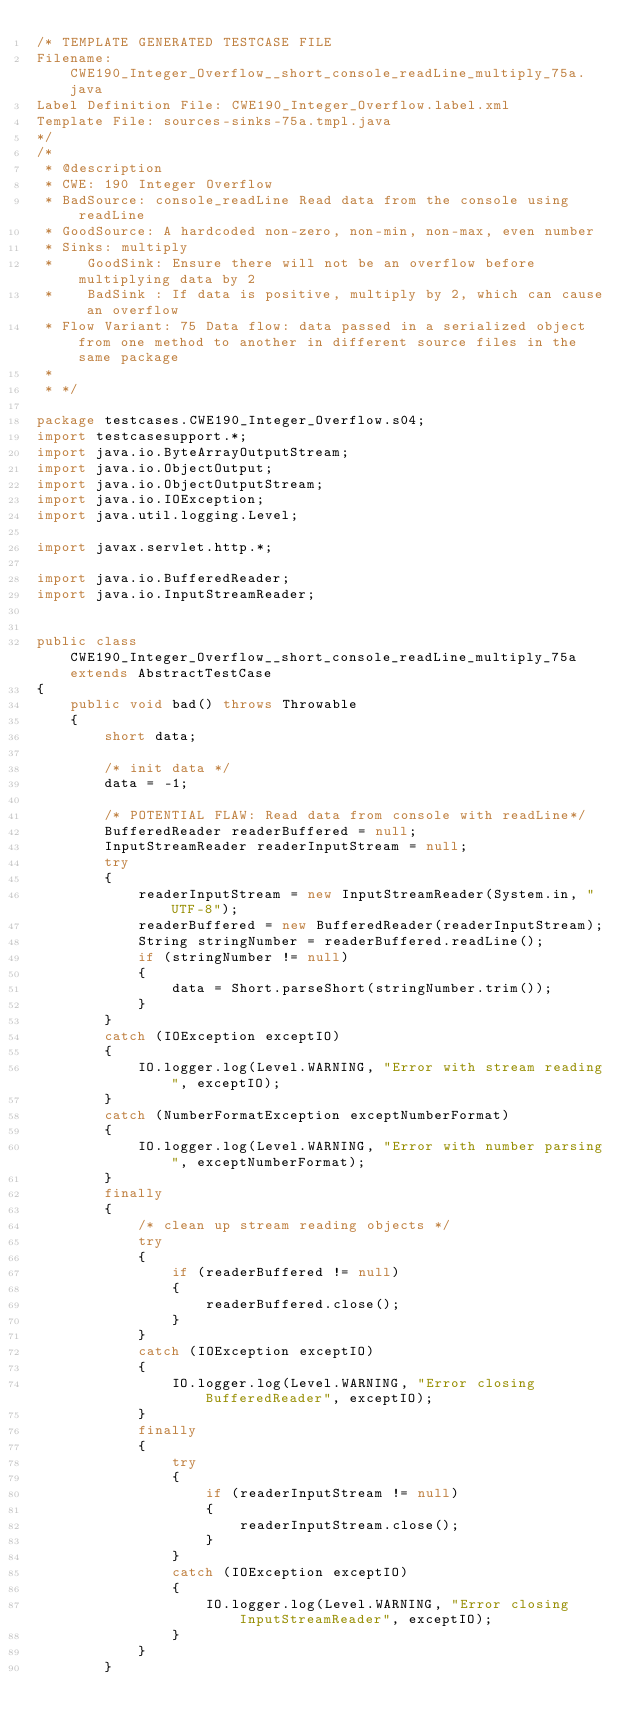<code> <loc_0><loc_0><loc_500><loc_500><_Java_>/* TEMPLATE GENERATED TESTCASE FILE
Filename: CWE190_Integer_Overflow__short_console_readLine_multiply_75a.java
Label Definition File: CWE190_Integer_Overflow.label.xml
Template File: sources-sinks-75a.tmpl.java
*/
/*
 * @description
 * CWE: 190 Integer Overflow
 * BadSource: console_readLine Read data from the console using readLine
 * GoodSource: A hardcoded non-zero, non-min, non-max, even number
 * Sinks: multiply
 *    GoodSink: Ensure there will not be an overflow before multiplying data by 2
 *    BadSink : If data is positive, multiply by 2, which can cause an overflow
 * Flow Variant: 75 Data flow: data passed in a serialized object from one method to another in different source files in the same package
 *
 * */

package testcases.CWE190_Integer_Overflow.s04;
import testcasesupport.*;
import java.io.ByteArrayOutputStream;
import java.io.ObjectOutput;
import java.io.ObjectOutputStream;
import java.io.IOException;
import java.util.logging.Level;

import javax.servlet.http.*;

import java.io.BufferedReader;
import java.io.InputStreamReader;


public class CWE190_Integer_Overflow__short_console_readLine_multiply_75a extends AbstractTestCase
{
    public void bad() throws Throwable
    {
        short data;

        /* init data */
        data = -1;

        /* POTENTIAL FLAW: Read data from console with readLine*/
        BufferedReader readerBuffered = null;
        InputStreamReader readerInputStream = null;
        try
        {
            readerInputStream = new InputStreamReader(System.in, "UTF-8");
            readerBuffered = new BufferedReader(readerInputStream);
            String stringNumber = readerBuffered.readLine();
            if (stringNumber != null)
            {
                data = Short.parseShort(stringNumber.trim());
            }
        }
        catch (IOException exceptIO)
        {
            IO.logger.log(Level.WARNING, "Error with stream reading", exceptIO);
        }
        catch (NumberFormatException exceptNumberFormat)
        {
            IO.logger.log(Level.WARNING, "Error with number parsing", exceptNumberFormat);
        }
        finally
        {
            /* clean up stream reading objects */
            try
            {
                if (readerBuffered != null)
                {
                    readerBuffered.close();
                }
            }
            catch (IOException exceptIO)
            {
                IO.logger.log(Level.WARNING, "Error closing BufferedReader", exceptIO);
            }
            finally
            {
                try
                {
                    if (readerInputStream != null)
                    {
                        readerInputStream.close();
                    }
                }
                catch (IOException exceptIO)
                {
                    IO.logger.log(Level.WARNING, "Error closing InputStreamReader", exceptIO);
                }
            }
        }
</code> 